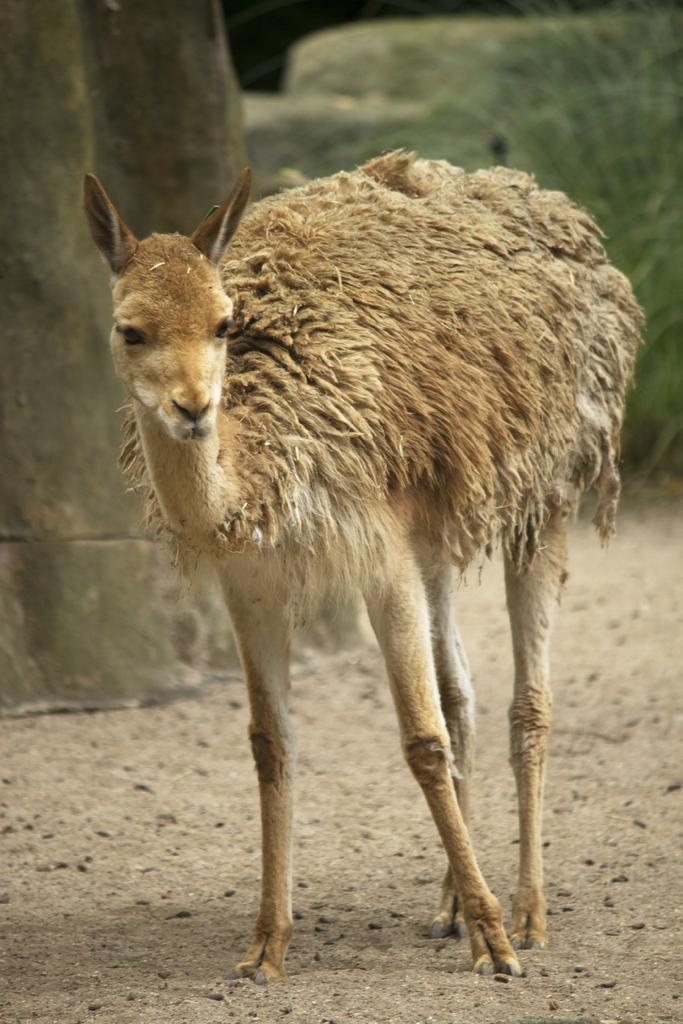What is on the ground in the image? There is an animal on the ground in the image. What can be seen on the left side of the image? There is an object on the left side of the image. How would you describe the background of the image? The background of the image is blurred. Can you see any regret in the animal's expression in the image? There is no indication of regret in the animal's expression in the image, as expressions are not visible in the provided facts. What town is visible in the background of the image? There is no town visible in the background of the image; the background is blurred. 